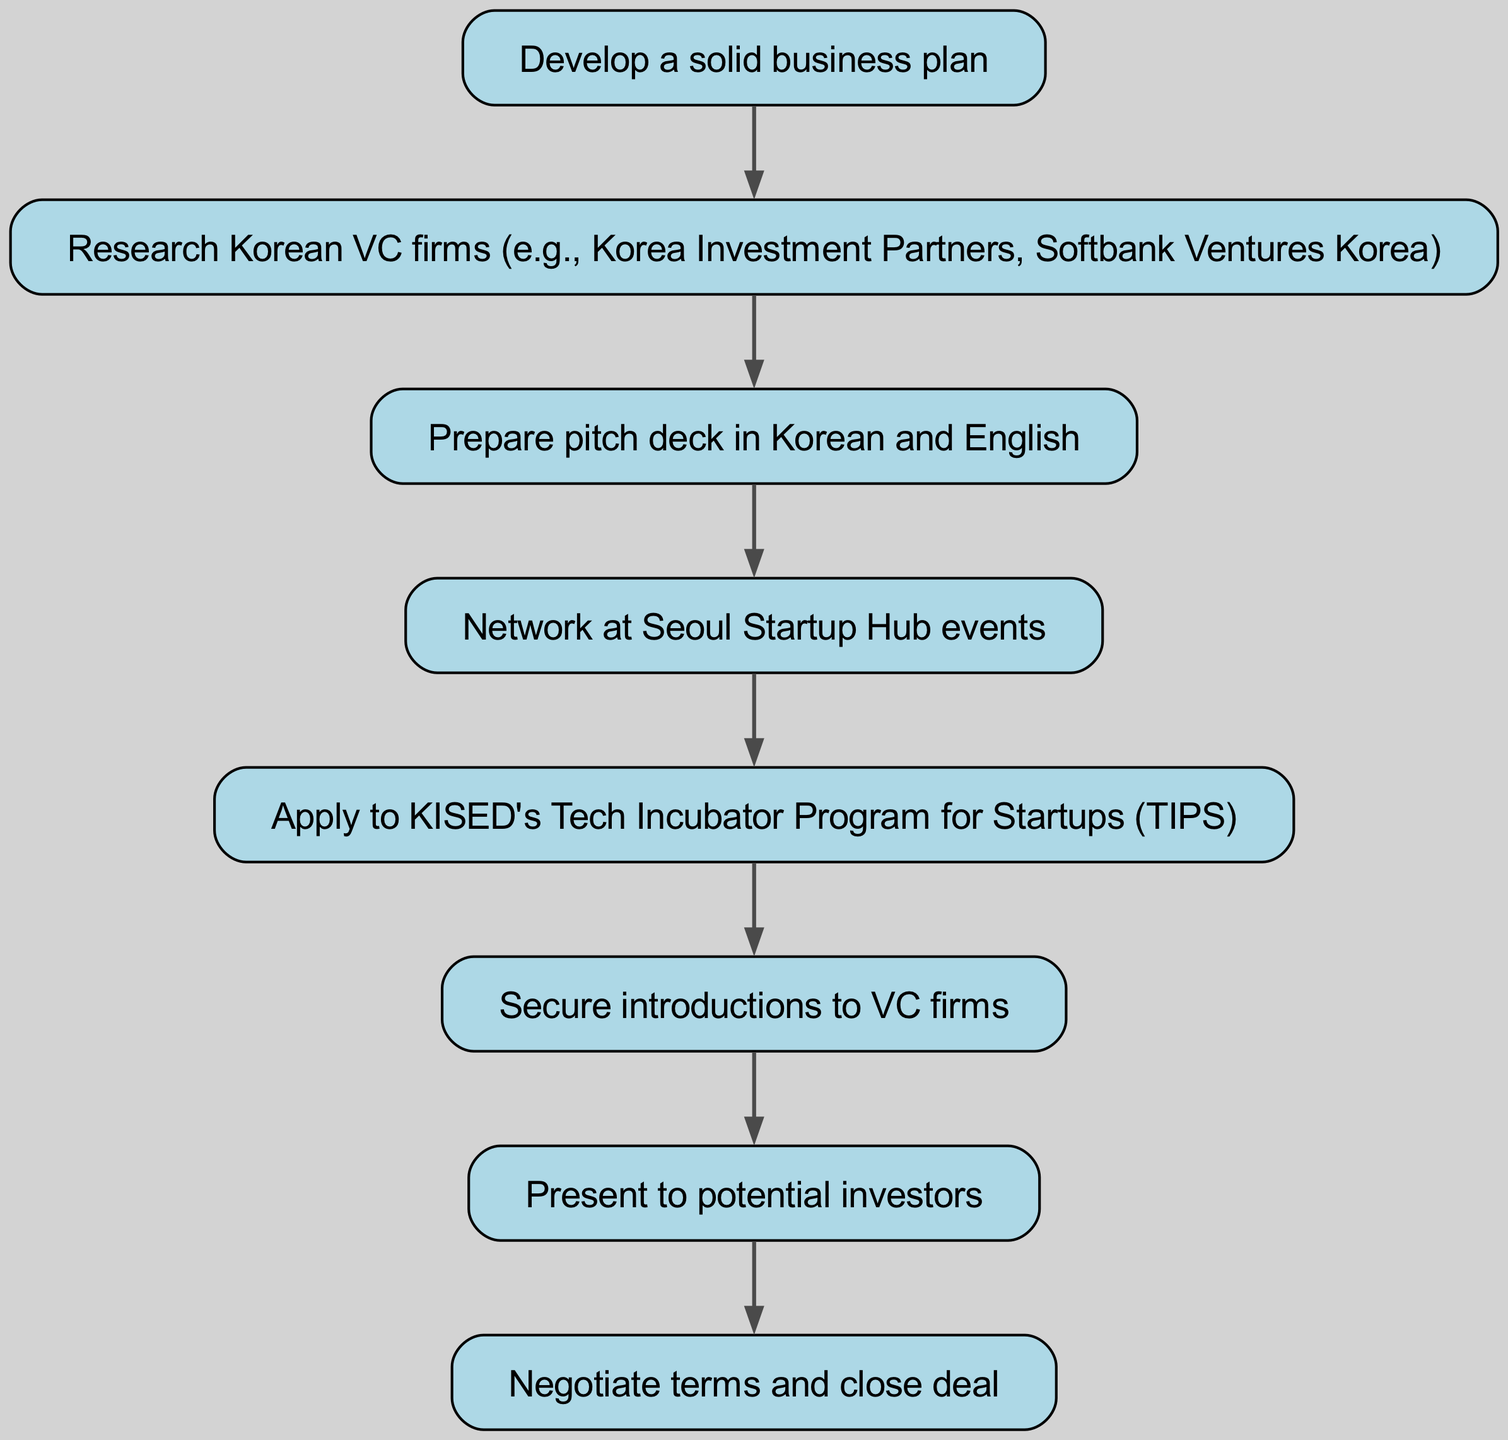what is the first step to secure funding? The first step in the diagram is represented by the node labeled "Develop a solid business plan." It is indicated as the starting point of the flow chart, leading to the next step.
Answer: Develop a solid business plan how many nodes are present in the diagram? To determine the number of nodes, we can count all the individual elements in the diagram. There are a total of 8 distinct steps listed in the elements section of the data provided.
Answer: 8 what connects the step 'Research Korean VC firms' to 'Prepare pitch deck in Korean and English'? There is a direct connection (an edge) between the nodes labeled "Research Korean VC firms" and "Prepare pitch deck in Korean and English." This edge indicates that after researching VC firms, the next action is to prepare the pitch deck.
Answer: Prepare pitch deck in Korean and English which step follows 'Network at Seoul Startup Hub events'? The diagram shows that the step "Network at Seoul Startup Hub events" is directly connected to "Apply to KISED's Tech Incubator Program for Startups (TIPS)," meaning that after networking, the next step is to apply to the TIPS program.
Answer: Apply to KISED's Tech Incubator Program for Startups (TIPS) how many edges lead to the final step 'Negotiate terms and close deal'? The final step in the diagram is "Negotiate terms and close deal," and there is only one edge leading to this step from the previous node labeled "Present to potential investors," indicating a singular flow into the final action of securing funding.
Answer: 1 what are the two languages in which the pitch deck should be prepared? The step "Prepare pitch deck in Korean and English" explicitly mentions two languages; hence, the pitch deck must be prepared in both of these languages as indicated in the corresponding node in the flow chart.
Answer: Korean and English what action comes immediately after securing introductions to VC firms? The step that follows the action of securing introductions to VC firms is "Present to potential investors." This direct connection indicates the logical flow of actions leading towards securing funding.
Answer: Present to potential investors what is the significance of 'Apply to KISED's Tech Incubator Program for Startups (TIPS)' in the flow? In the flow chart, applying to KISED's TIPS program represents a crucial step that enables startups to increase their credibility and access networks, ultimately facilitating introductions to potential VC firms. This is evident because it connects to the subsequent step of securing introductions.
Answer: Increase credibility and access networks 